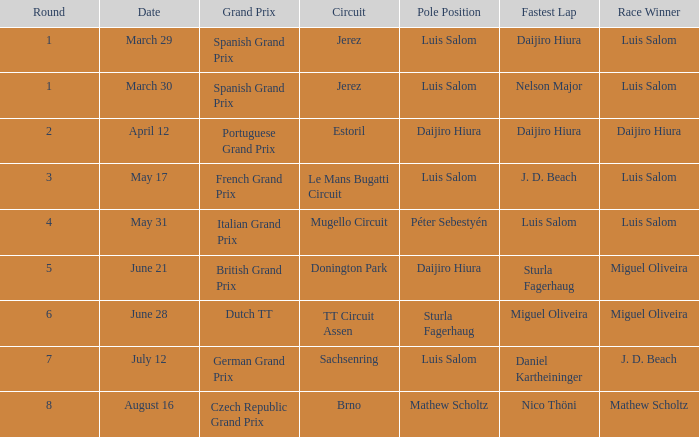Which round 5 Grand Prix had Daijiro Hiura at pole position?  British Grand Prix. 